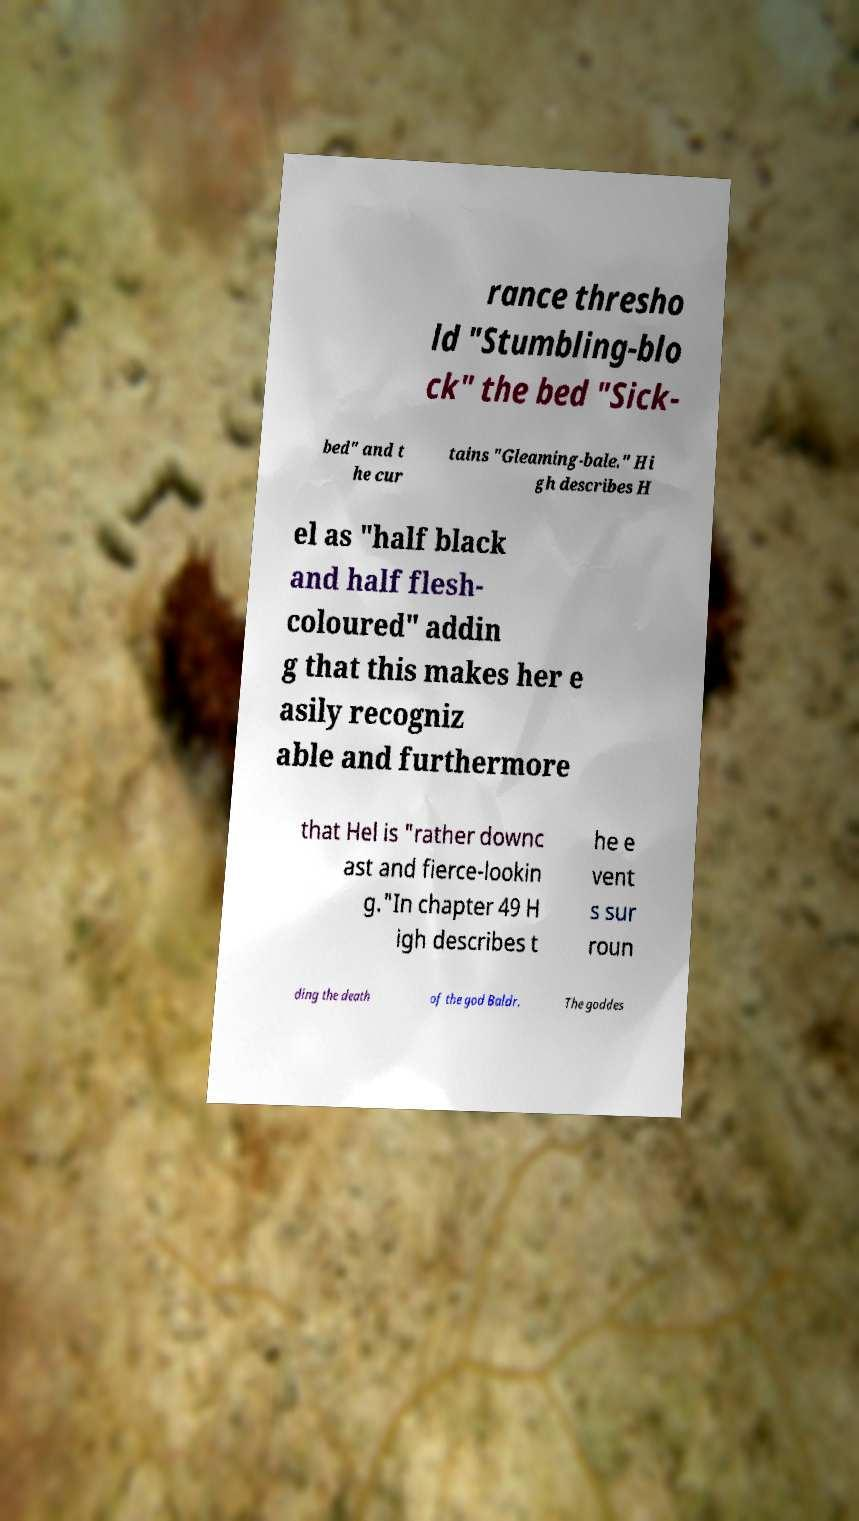Could you extract and type out the text from this image? rance thresho ld "Stumbling-blo ck" the bed "Sick- bed" and t he cur tains "Gleaming-bale." Hi gh describes H el as "half black and half flesh- coloured" addin g that this makes her e asily recogniz able and furthermore that Hel is "rather downc ast and fierce-lookin g."In chapter 49 H igh describes t he e vent s sur roun ding the death of the god Baldr. The goddes 